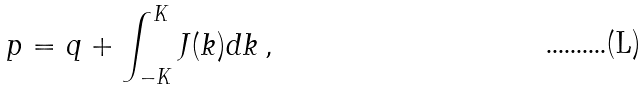Convert formula to latex. <formula><loc_0><loc_0><loc_500><loc_500>p = q + \int _ { - K } ^ { K } J ( k ) d k \, ,</formula> 